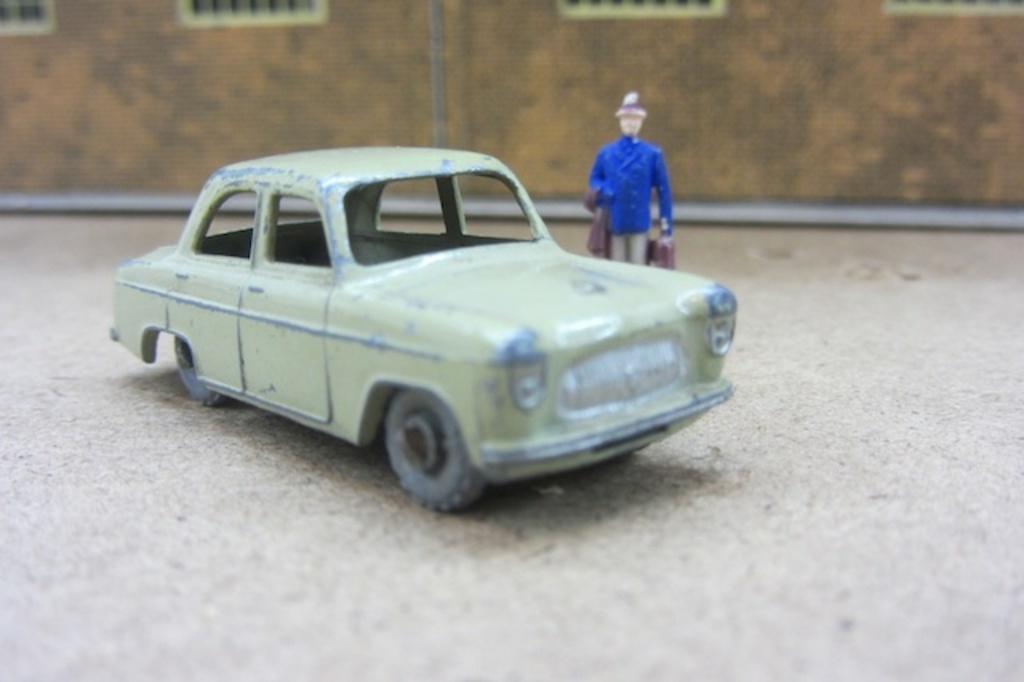Please provide a concise description of this image. In the image there is a toy car, beside the toy car there is a doll. 